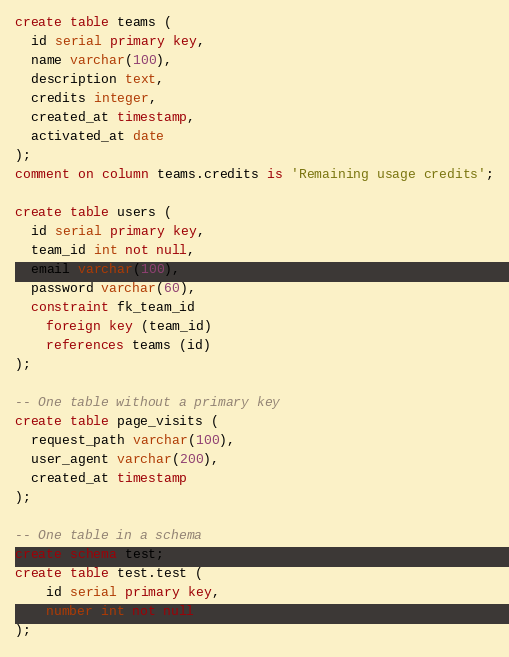Convert code to text. <code><loc_0><loc_0><loc_500><loc_500><_SQL_>create table teams (
  id serial primary key,
  name varchar(100),
  description text,
  credits integer,
  created_at timestamp,
  activated_at date
);
comment on column teams.credits is 'Remaining usage credits';

create table users (
  id serial primary key,
  team_id int not null,
  email varchar(100),
  password varchar(60),
  constraint fk_team_id
    foreign key (team_id)
    references teams (id)
);

-- One table without a primary key
create table page_visits (
  request_path varchar(100),
  user_agent varchar(200),
  created_at timestamp
);

-- One table in a schema
create schema test;
create table test.test (
    id serial primary key,
    number int not null
);
</code> 